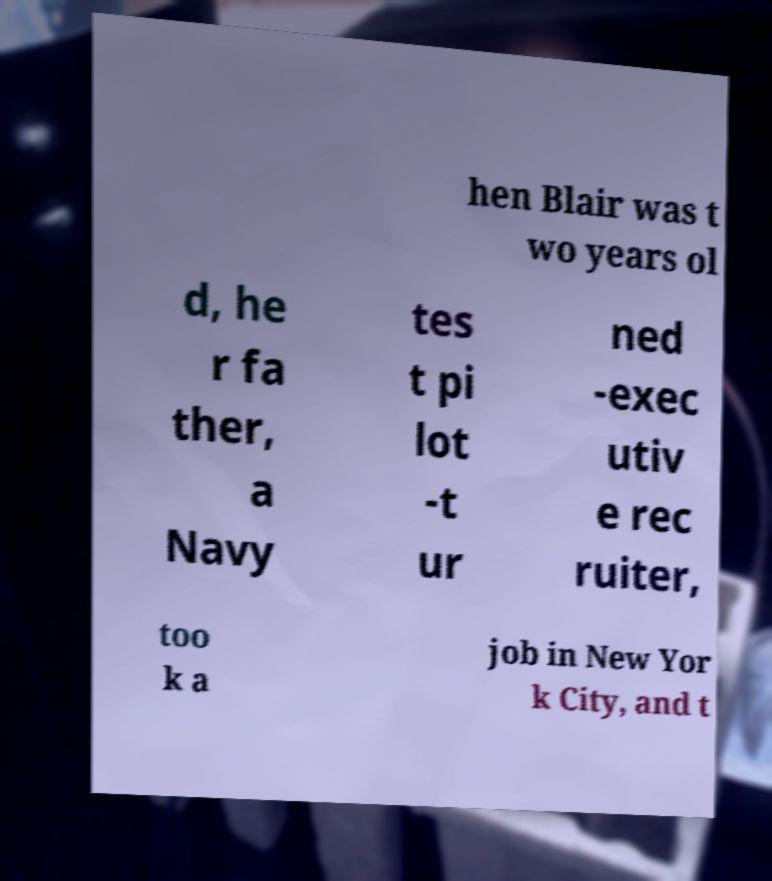For documentation purposes, I need the text within this image transcribed. Could you provide that? hen Blair was t wo years ol d, he r fa ther, a Navy tes t pi lot -t ur ned -exec utiv e rec ruiter, too k a job in New Yor k City, and t 